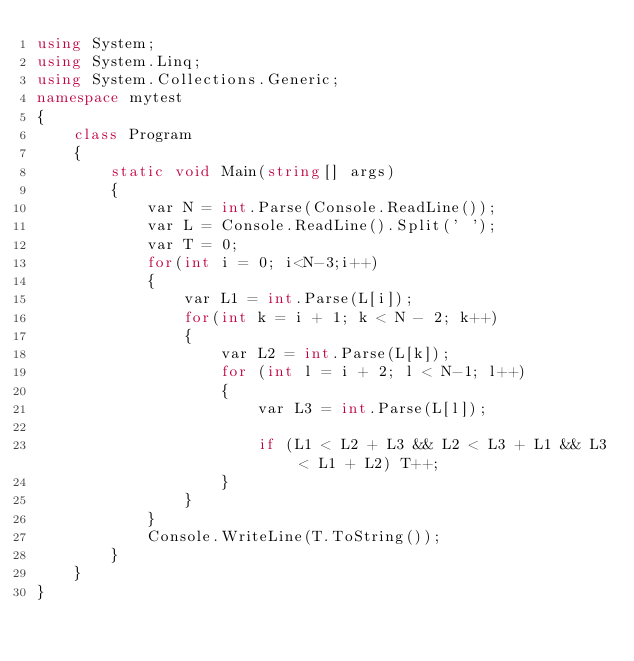Convert code to text. <code><loc_0><loc_0><loc_500><loc_500><_C#_>using System;
using System.Linq;
using System.Collections.Generic;
namespace mytest
{
    class Program
    {
        static void Main(string[] args)
        {
            var N = int.Parse(Console.ReadLine());
            var L = Console.ReadLine().Split(' ');
            var T = 0;
            for(int i = 0; i<N-3;i++)
            {
                var L1 = int.Parse(L[i]);
                for(int k = i + 1; k < N - 2; k++)
                {
                    var L2 = int.Parse(L[k]);
                    for (int l = i + 2; l < N-1; l++)
                    {
                        var L3 = int.Parse(L[l]);

                        if (L1 < L2 + L3 && L2 < L3 + L1 && L3 < L1 + L2) T++;
                    }
                }
            }
            Console.WriteLine(T.ToString());
        }
    }
}
</code> 